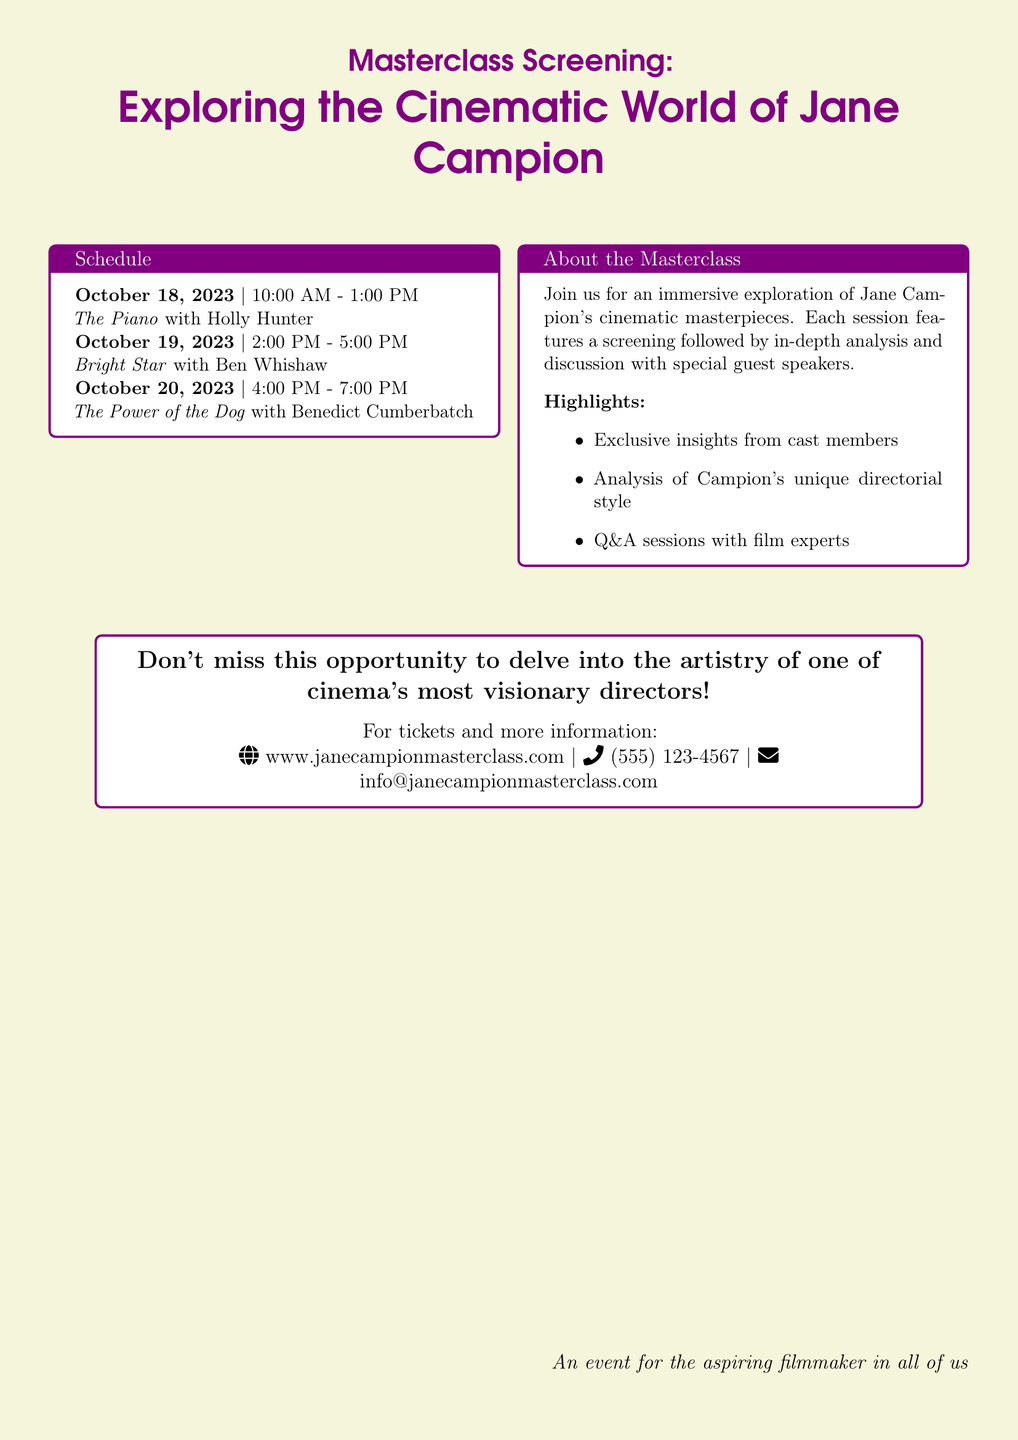What is the date of the first screening? The first screening is scheduled for October 18, 2023.
Answer: October 18, 2023 Who is featured in the first session? The first session features Holly Hunter in "The Piano."
Answer: Holly Hunter What are the timings for the second screening? The second screening is from 2:00 PM to 5:00 PM.
Answer: 2:00 PM - 5:00 PM What is the focus of the masterclass? The masterclass focuses on exploring Jane Campion's cinematic masterpieces.
Answer: Cinematic masterpieces How many films are listed in the schedule? There are three films listed in the schedule for the masterclass.
Answer: Three What is included in the highlights section of the masterclass? The highlights include exclusive insights from cast members.
Answer: Exclusive insights from cast members What is the contact number for more information? The contact number provided is (555) 123-4567.
Answer: (555) 123-4567 What is the purpose of the event based on the last statement? The purpose of the event is to engage aspiring filmmakers.
Answer: Aspiring filmmakers 